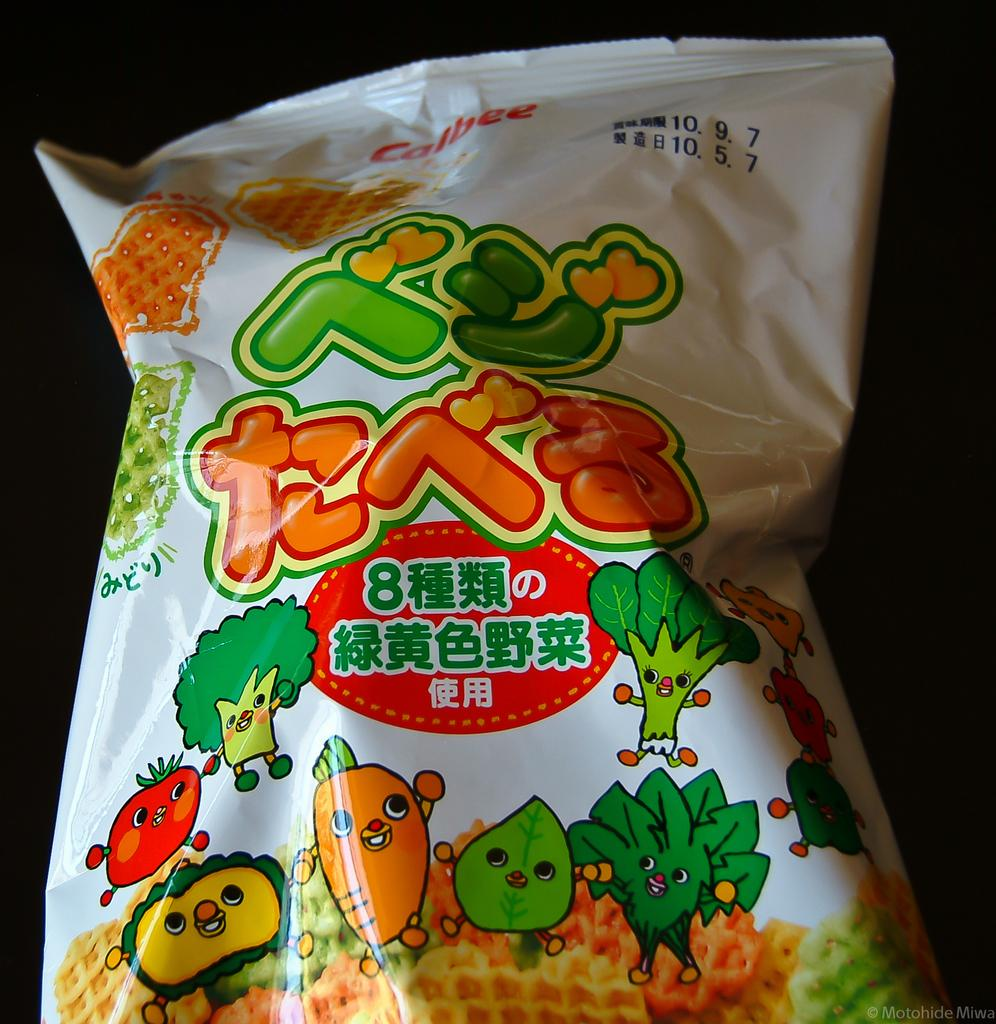What is present in the image? There is a packet in the image. What can be observed about the background of the image? The background of the image is dark. Can you tell me who is arguing with the lawyer in the image? There is no argument or lawyer present in the image; it only features a packet and a dark background. What color is the eye in the image? There is no eye present in the image. 